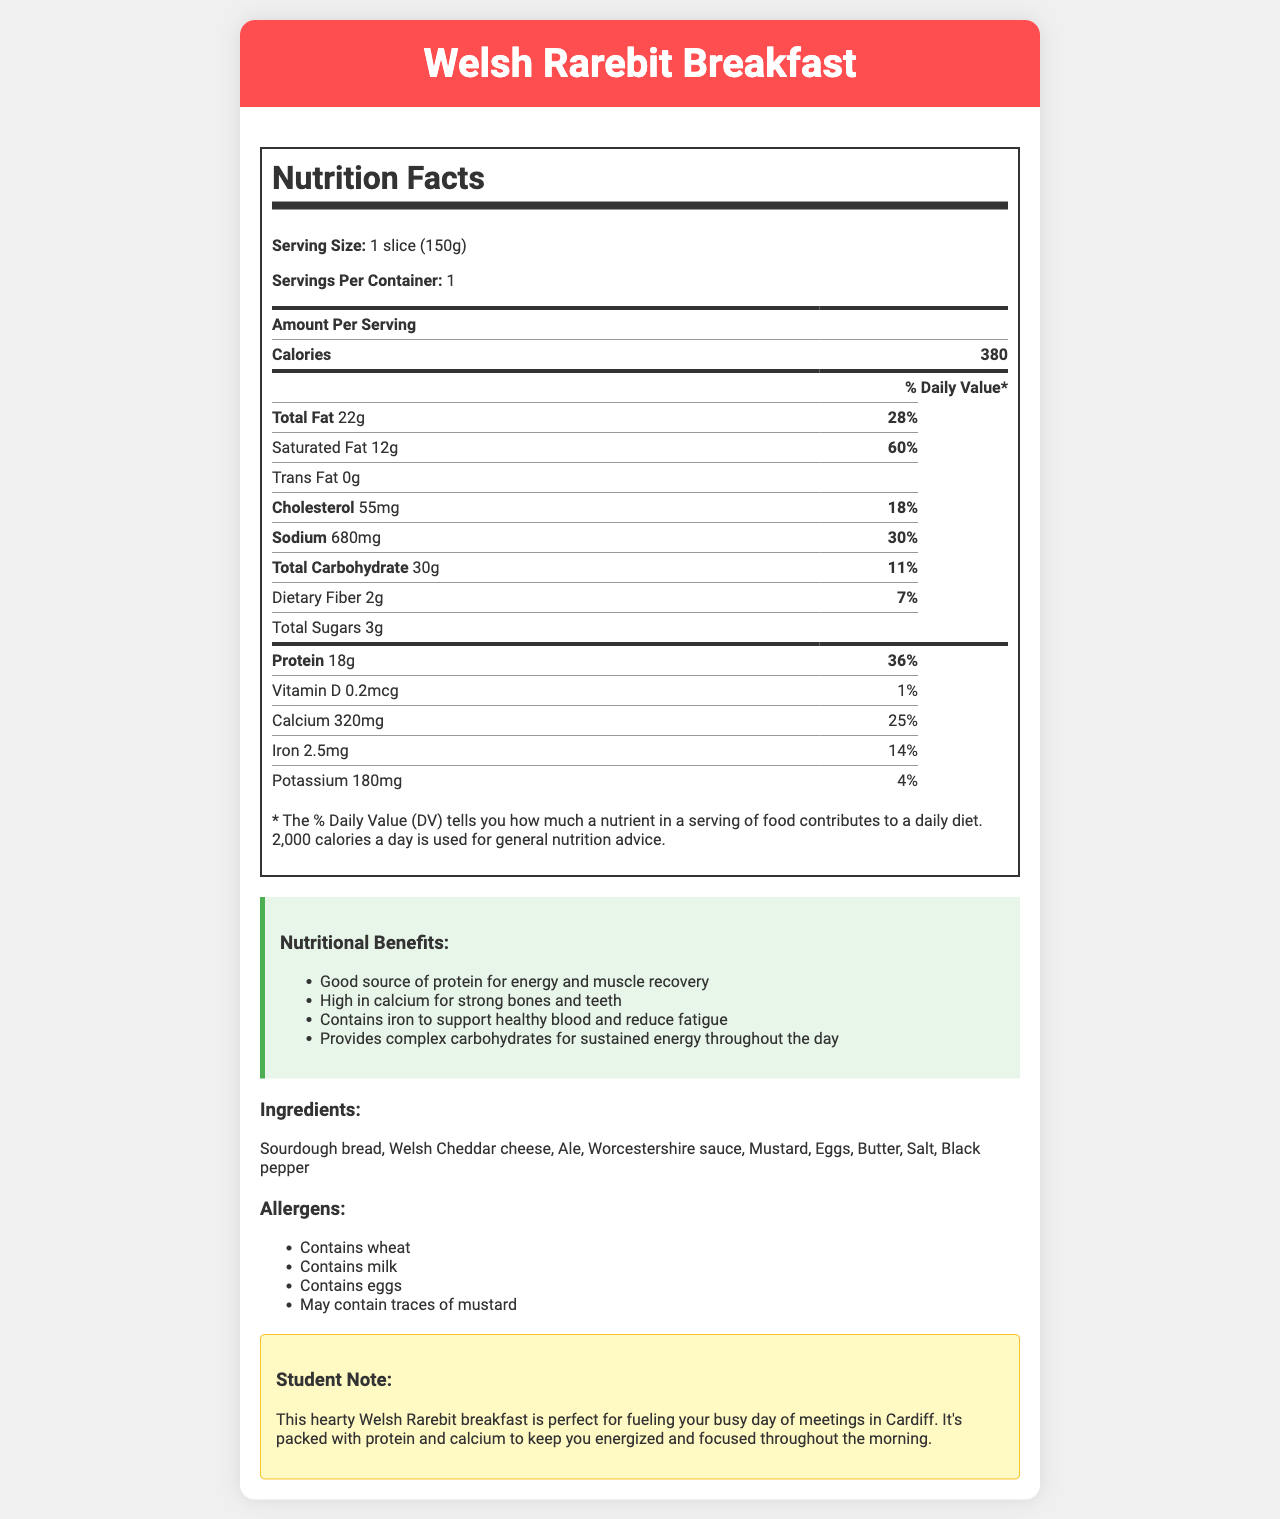what is the serving size for the Welsh Rarebit Breakfast? The serving size is listed at the top of the Nutrition Facts label as 1 slice (150g).
Answer: 1 slice (150g) how many calories are in one serving of Welsh Rarebit Breakfast? The number of calories per serving is clearly stated as 380 in the Amount Per Serving section of the Nutrition Facts label.
Answer: 380 what is the amount of protein in one serving? The amount of protein per serving is mentioned as 18g under the Nutrition Facts label.
Answer: 18g what is the % Daily Value for Saturated Fat in one serving? The % Daily Value for Saturated Fat is listed as 60% on the Nutrition Facts label.
Answer: 60% list the allergens found in Welsh Rarebit Breakfast. The allergens are listed under the Allergens section of the document.
Answer: Contains wheat, Contains milk, Contains eggs, May contain traces of mustard which ingredient is not mentioned in the list of allergens? A. Sourdough bread B. Eggs C. Salt D. Worcestershire sauce The allergens list includes wheat, milk, eggs, and traces of mustard, but salt is not mentioned.
Answer: C. Salt how much calcium is in one serving? A. 180mg B. 320mg C. 2.5mg D. 0.2mcg The Nutrition Facts label shows that one serving contains 320mg of calcium.
Answer: B. 320mg is Welsh Rarebit Breakfast a good source of protein? The Nutrition Facts label states that the dish contains 18g of protein, which is 36% of the Daily Value, making it a good source of protein.
Answer: Yes describe the nutritional benefits mentioned for Welsh Rarebit Breakfast. The document lists these benefits explicitly under the Nutritional Benefits section.
Answer: The nutritional benefits include being a good source of protein for energy and muscle recovery, high in calcium for strong bones and teeth, contains iron to support healthy blood and reduce fatigue, and provides complex carbohydrates for sustained energy throughout the day. is there information on where to buy this product? The document does not provide any details on where to purchase the Welsh Rarebit Breakfast.
Answer: Not enough information summarize the main idea of the document. The document is designed to inform readers about the nutritional content and benefits of the Welsh Rarebit Breakfast, alongside ingredient and allergen details, making it suitable for individuals looking to fuel their day with a nutritious breakfast in Cardiff.
Answer: The document provides comprehensive information about Welsh Rarebit Breakfast, including its nutritional facts such as calories, fats, protein, vitamins, and minerals. It outlines the serving size and servings per container, nutritional benefits, ingredients, allergens, and a special note indicating its suitability for a busy student in Cardiff. 